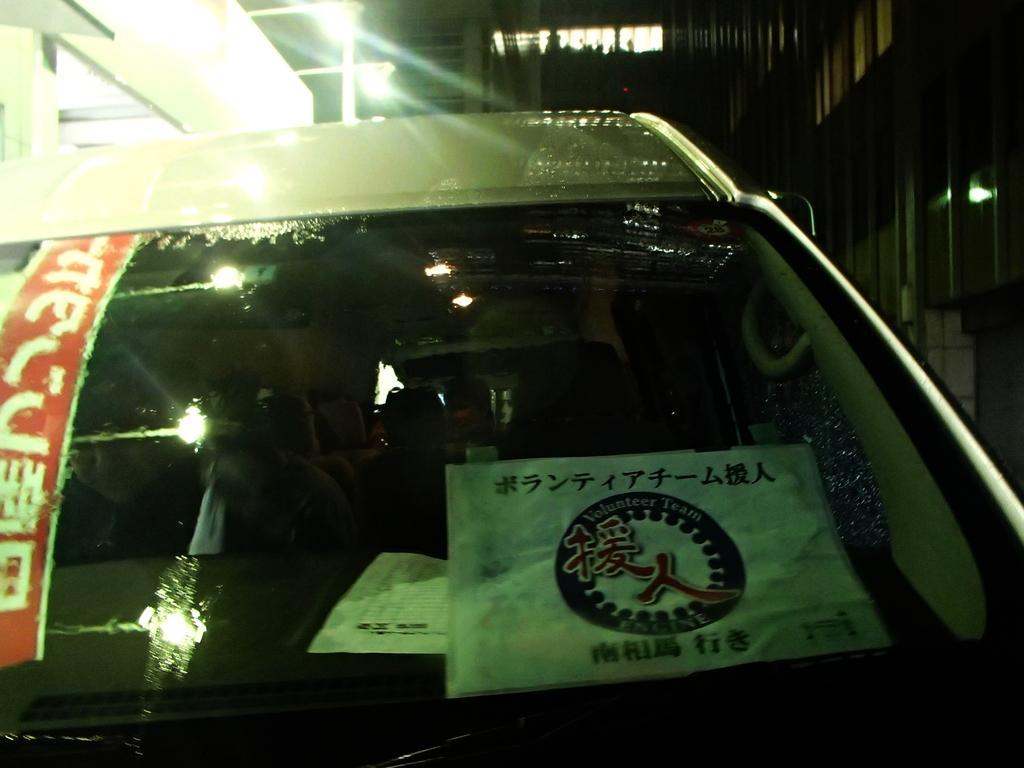Please provide a concise description of this image. In the foreground of the picture there is a car, to the car there are stickers. In the background there are buildings, light, windows and other objects. 